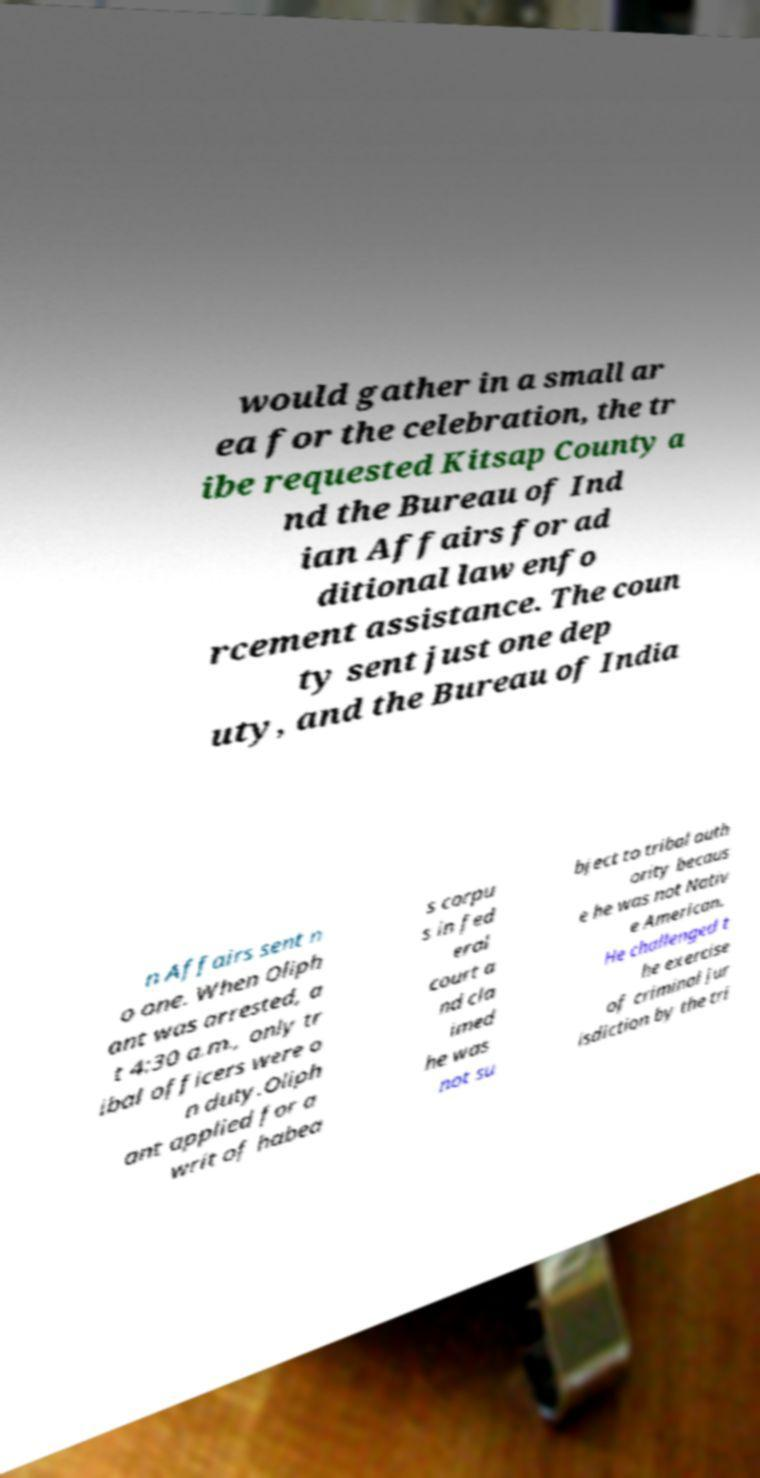For documentation purposes, I need the text within this image transcribed. Could you provide that? would gather in a small ar ea for the celebration, the tr ibe requested Kitsap County a nd the Bureau of Ind ian Affairs for ad ditional law enfo rcement assistance. The coun ty sent just one dep uty, and the Bureau of India n Affairs sent n o one. When Oliph ant was arrested, a t 4:30 a.m., only tr ibal officers were o n duty.Oliph ant applied for a writ of habea s corpu s in fed eral court a nd cla imed he was not su bject to tribal auth ority becaus e he was not Nativ e American. He challenged t he exercise of criminal jur isdiction by the tri 